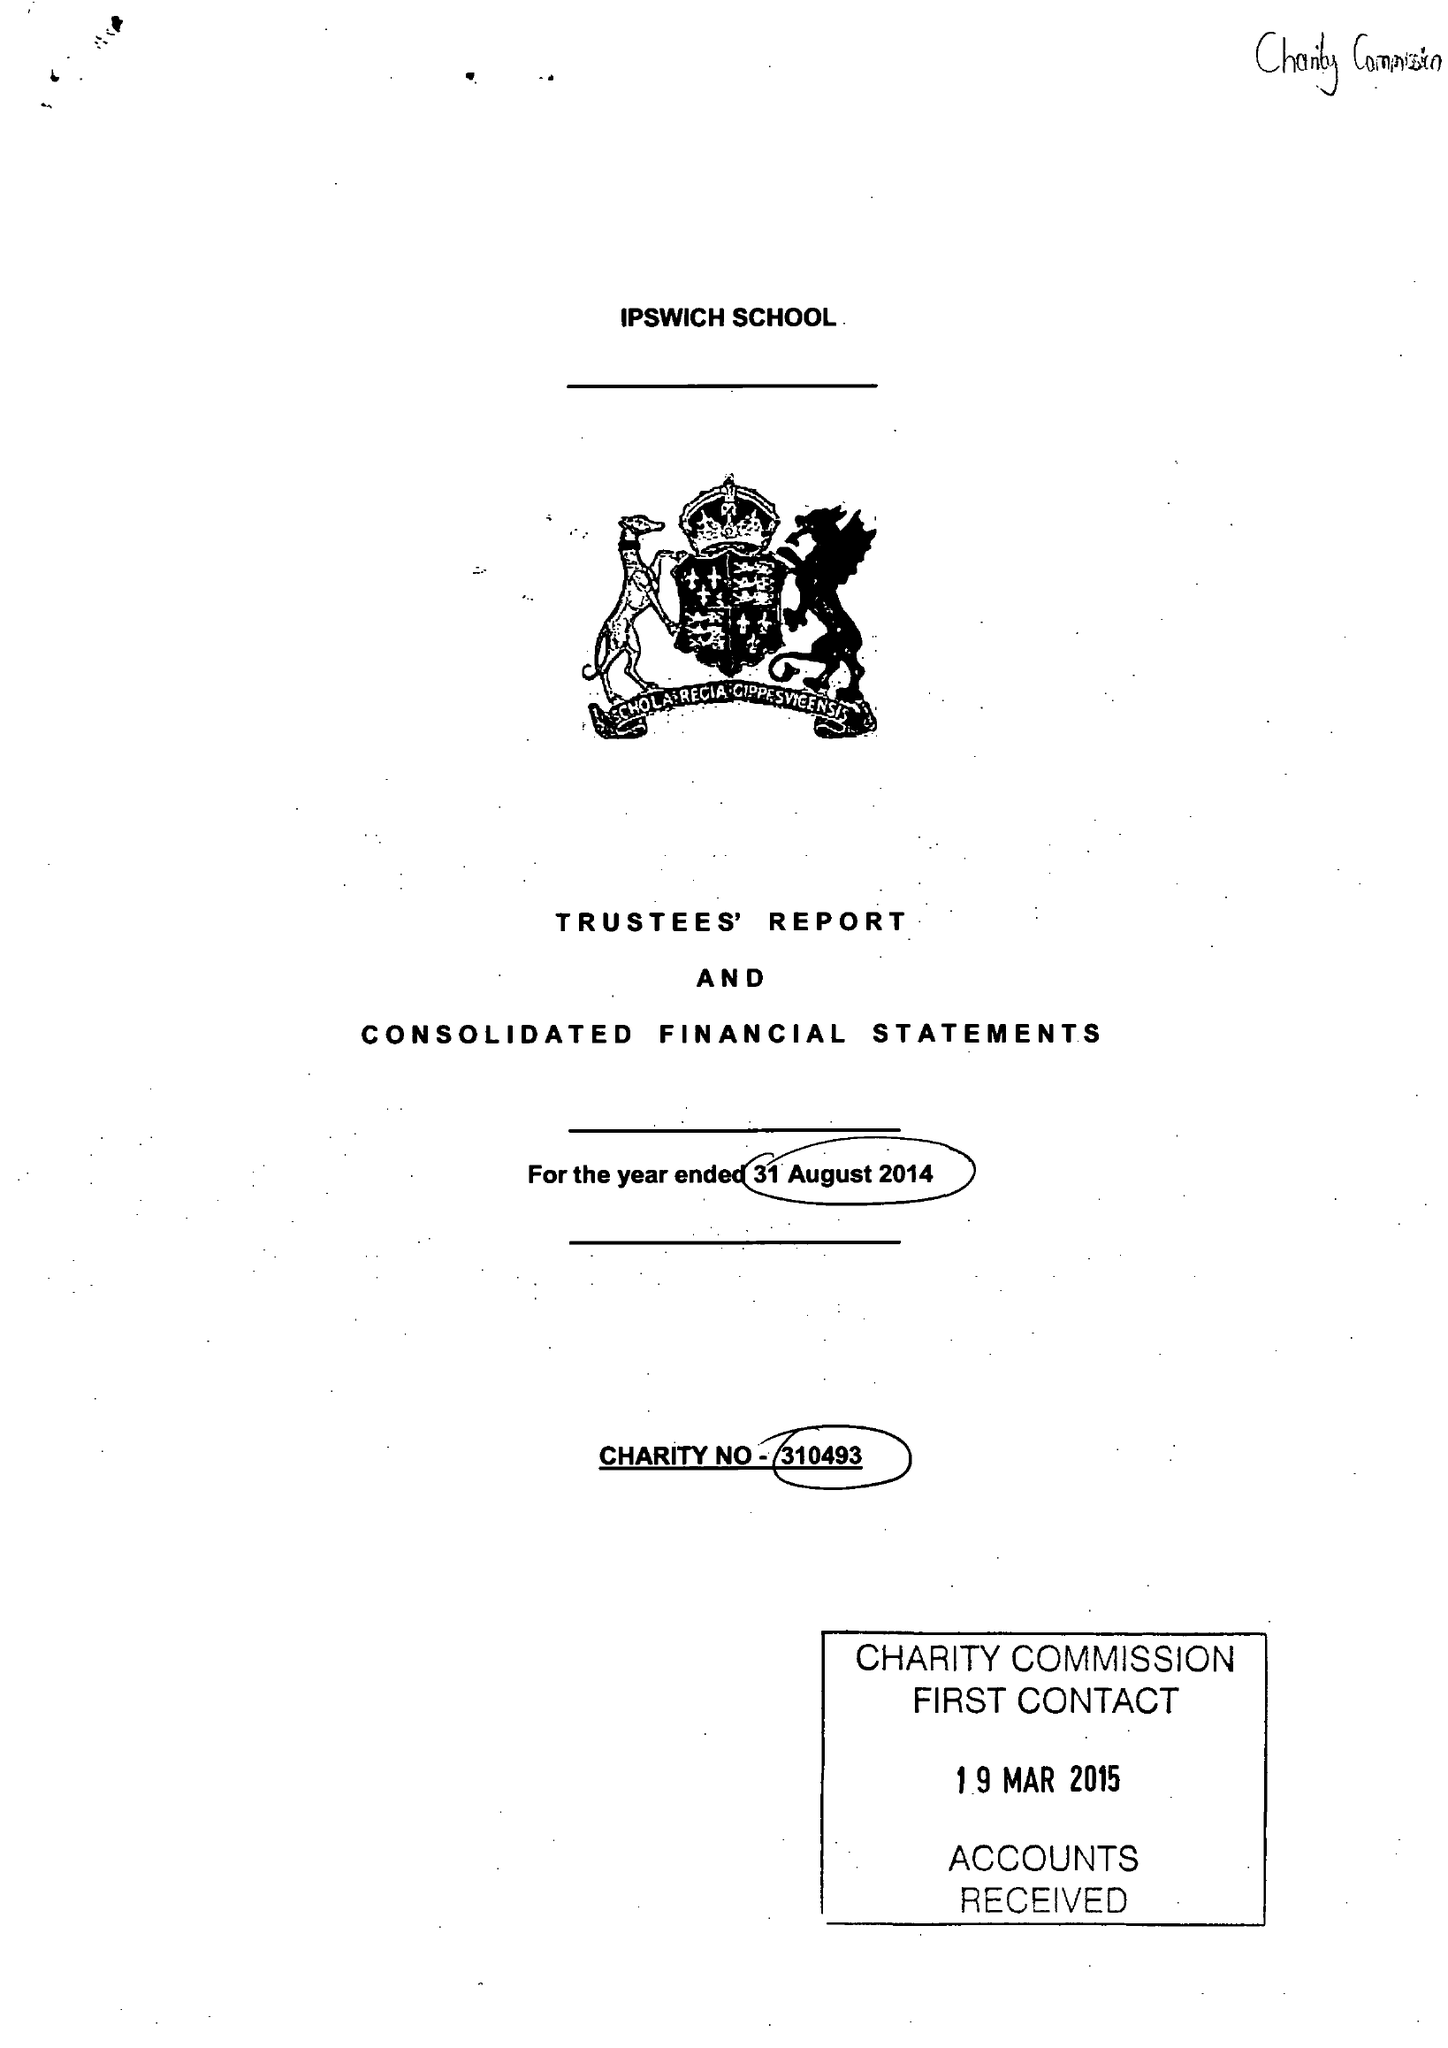What is the value for the report_date?
Answer the question using a single word or phrase. 2014-08-31 